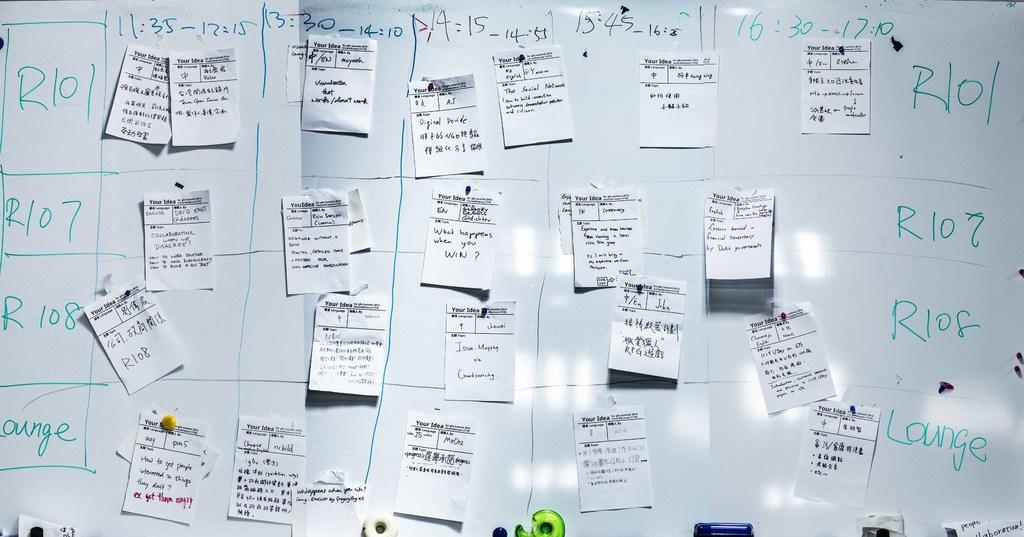<image>
Present a compact description of the photo's key features. a chart of letters R101, R107,  Lounge and times with many pieces of paper are hanging on a white board 